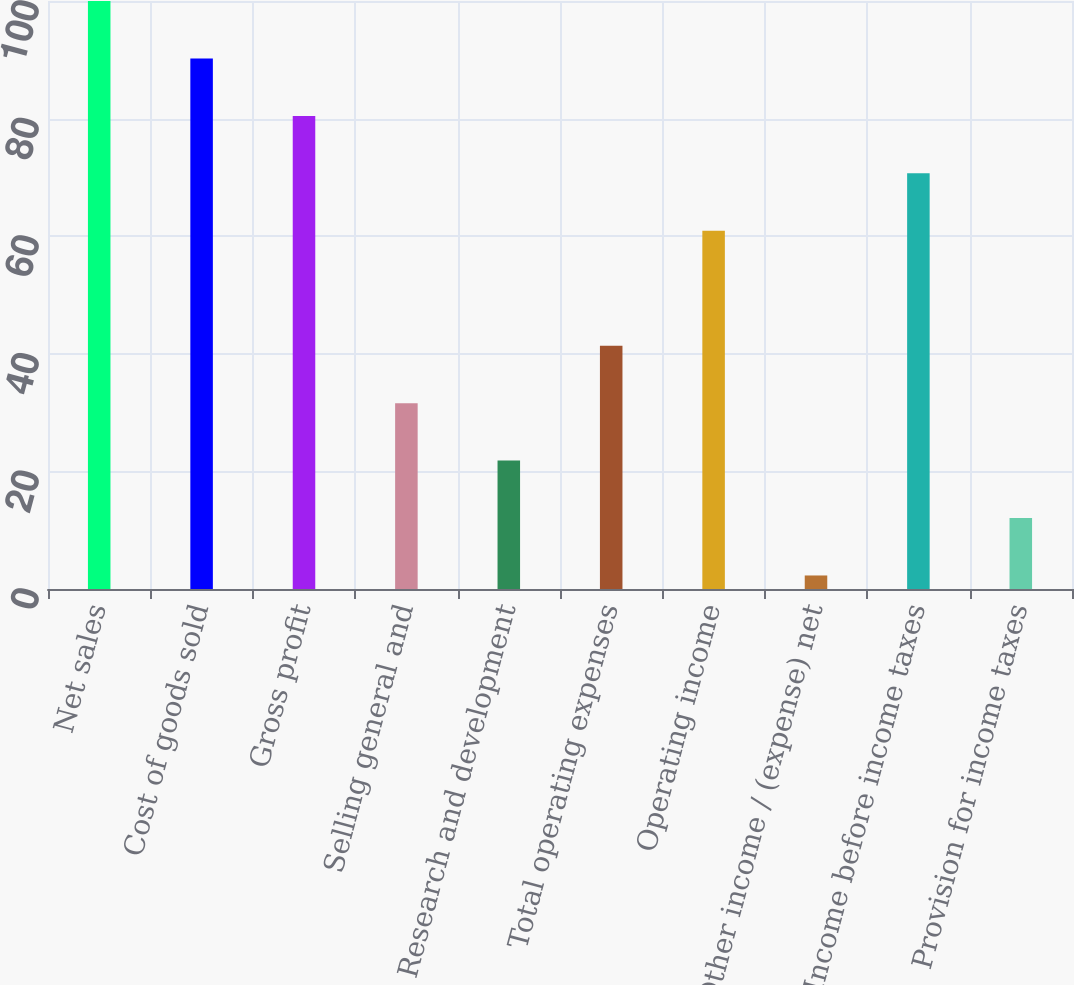<chart> <loc_0><loc_0><loc_500><loc_500><bar_chart><fcel>Net sales<fcel>Cost of goods sold<fcel>Gross profit<fcel>Selling general and<fcel>Research and development<fcel>Total operating expenses<fcel>Operating income<fcel>Other income / (expense) net<fcel>Income before income taxes<fcel>Provision for income taxes<nl><fcel>100<fcel>90.23<fcel>80.46<fcel>31.61<fcel>21.84<fcel>41.38<fcel>60.92<fcel>2.3<fcel>70.69<fcel>12.07<nl></chart> 